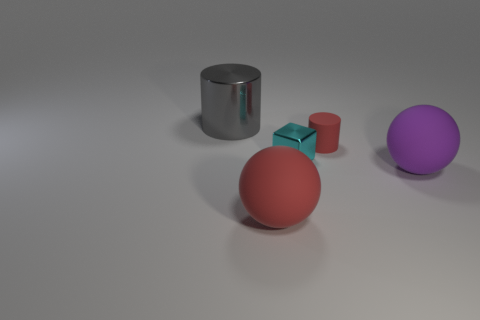Add 1 tiny purple rubber balls. How many objects exist? 6 Subtract all balls. How many objects are left? 3 Subtract all red matte objects. Subtract all purple matte spheres. How many objects are left? 2 Add 4 tiny red matte cylinders. How many tiny red matte cylinders are left? 5 Add 1 big metallic cylinders. How many big metallic cylinders exist? 2 Subtract 0 purple cylinders. How many objects are left? 5 